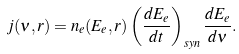Convert formula to latex. <formula><loc_0><loc_0><loc_500><loc_500>j ( \nu , r ) = n _ { e } ( E _ { e } , r ) \left ( \frac { d E _ { e } } { d t } \right ) _ { s y n } \frac { d E _ { e } } { d \nu } .</formula> 